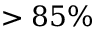Convert formula to latex. <formula><loc_0><loc_0><loc_500><loc_500>> 8 5 \%</formula> 